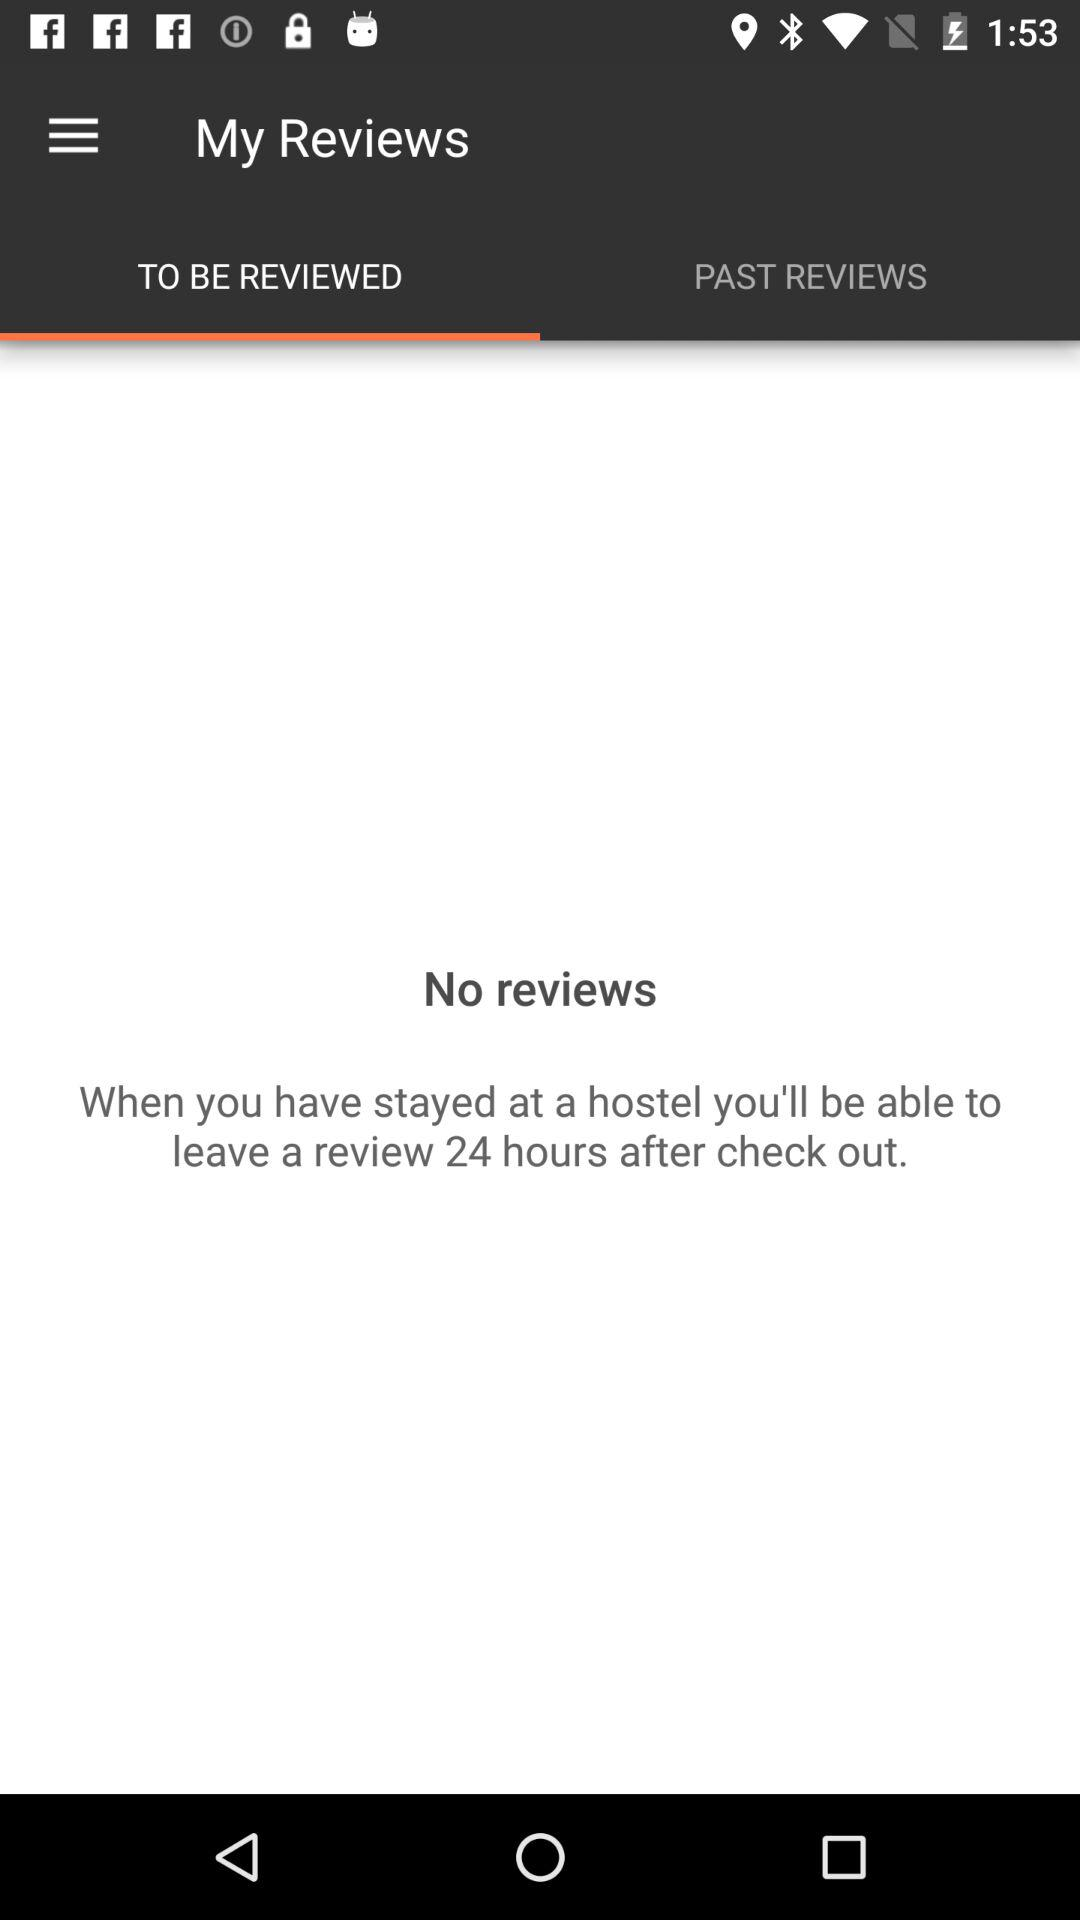Which tab is currently selected? The currently selected tab is "TO BE REVIEWED". 